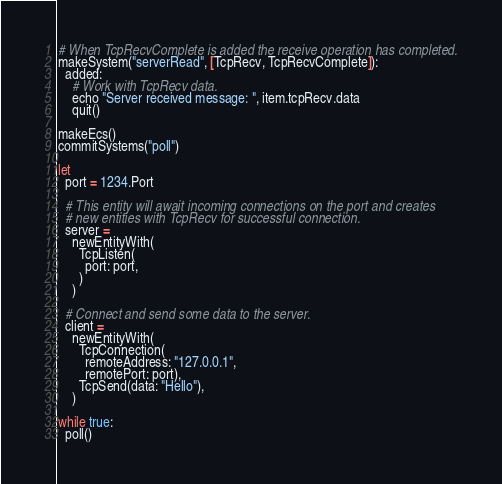<code> <loc_0><loc_0><loc_500><loc_500><_Nim_>
# When TcpRecvComplete is added the receive operation has completed.
makeSystem("serverRead", [TcpRecv, TcpRecvComplete]):
  added:
    # Work with TcpRecv data.
    echo "Server received message: ", item.tcpRecv.data
    quit()

makeEcs()
commitSystems("poll")

let
  port = 1234.Port

  # This entity will await incoming connections on the port and creates
  # new entities with TcpRecv for successful connection.
  server =
    newEntityWith(
      TcpListen(
        port: port,
      )
    )

  # Connect and send some data to the server.
  client =
    newEntityWith(
      TcpConnection(
        remoteAddress: "127.0.0.1",
        remotePort: port),
      TcpSend(data: "Hello"),
    )

while true:
  poll()</code> 